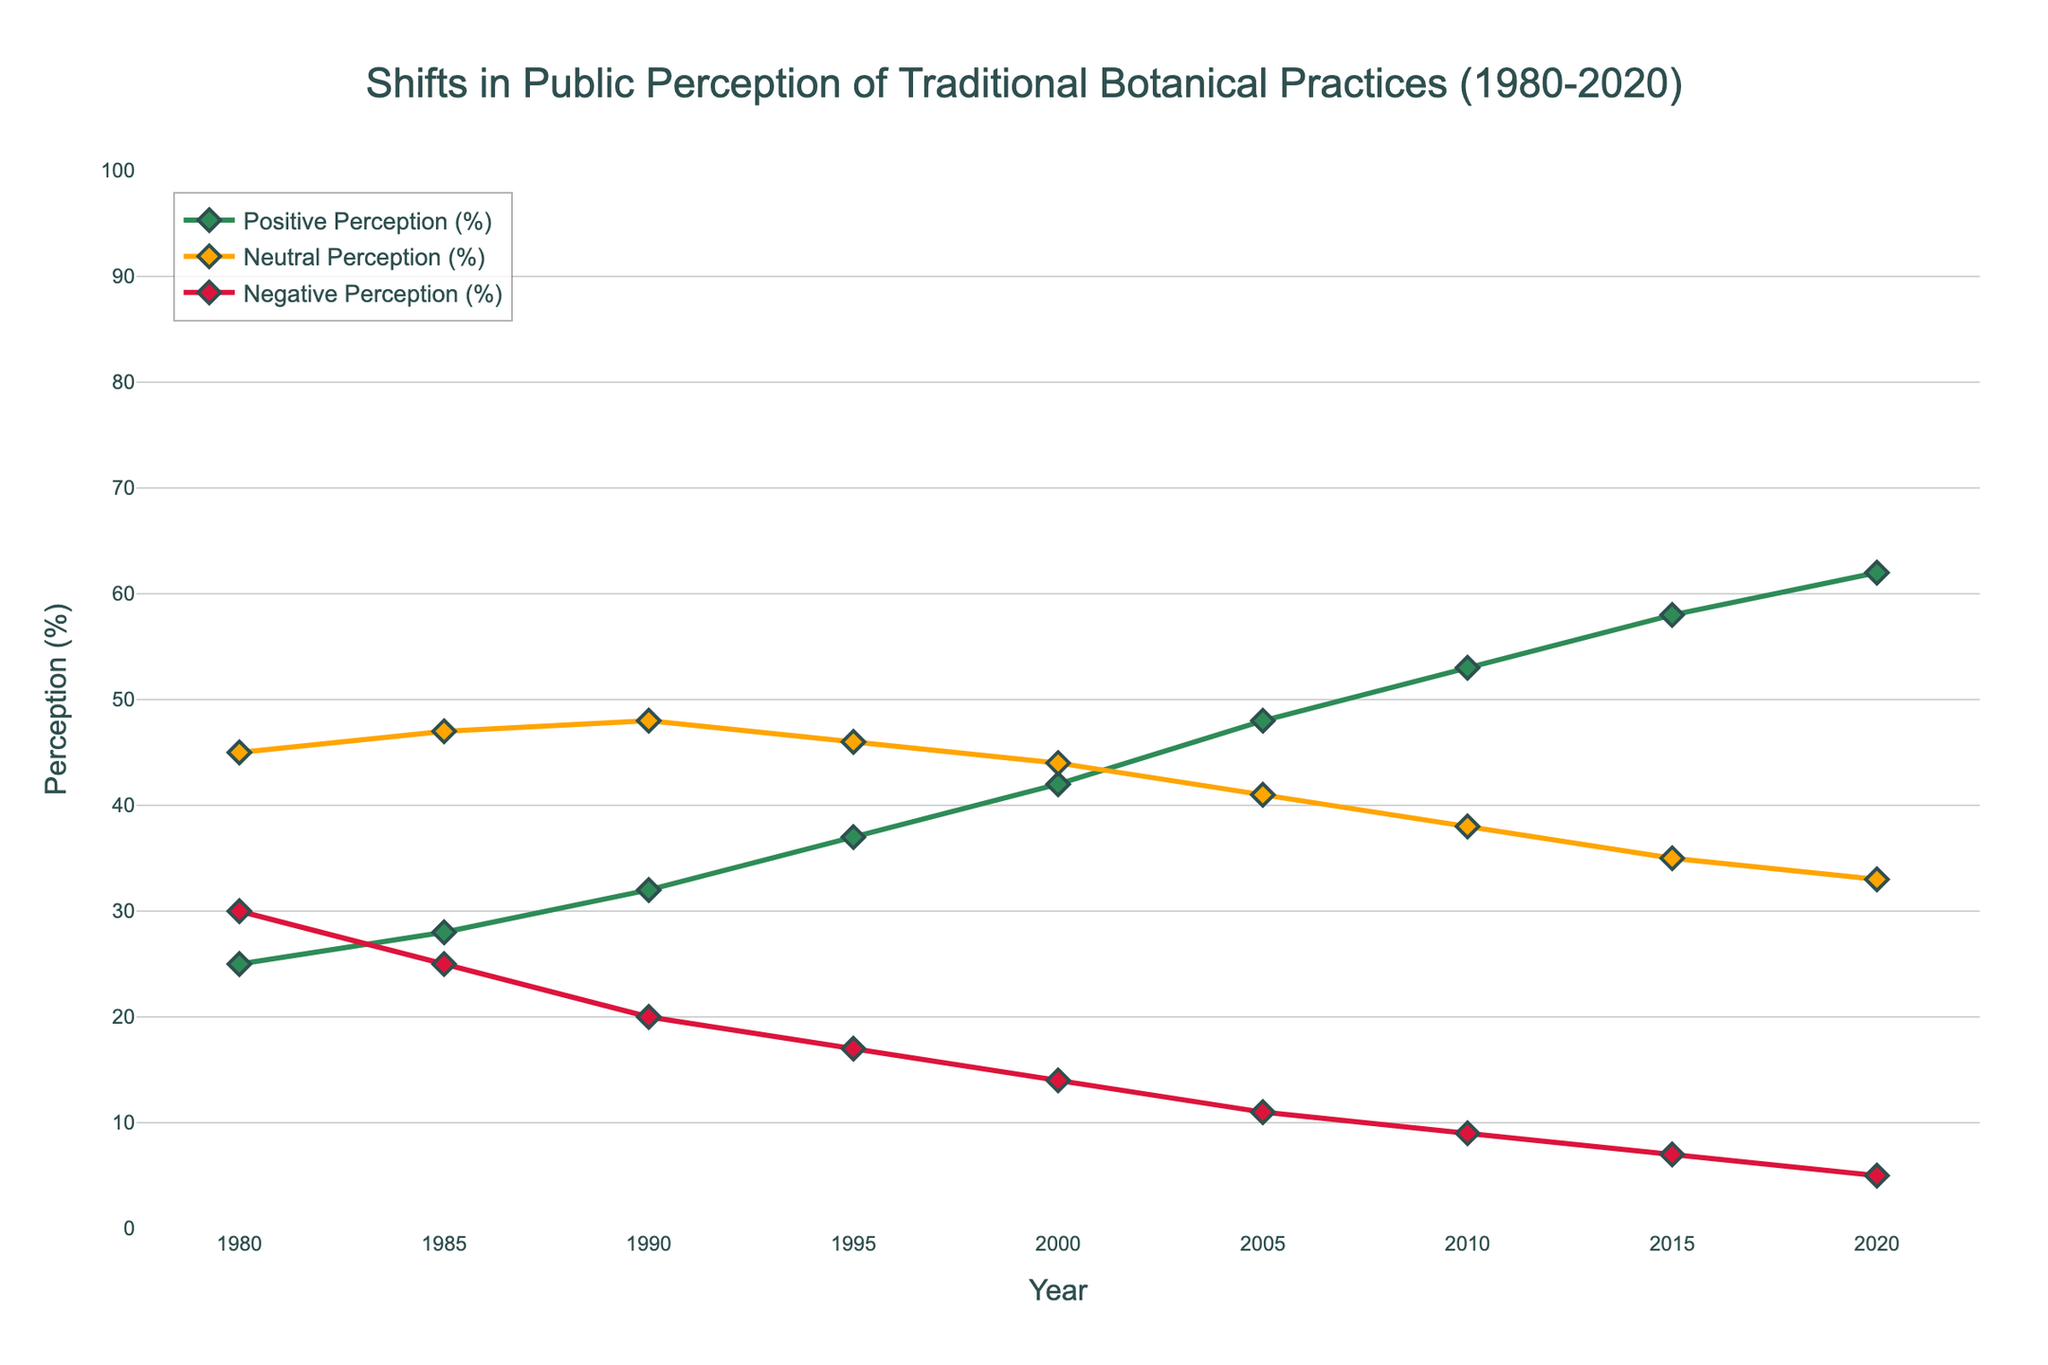What's the trend in Positive Perception (%) from 1980 to 2020? To find the trend, observe the changes in the line corresponding to Positive Perception (%). The values increase from 25% in 1980 to 62% in 2020, showing an upward trend.
Answer: Upward trend Which perception category has the lowest percentage in 2020? Identify the lowest point among the three perception lines in 2020. The Positive Perception line is at 62%, Neutral Perception is at 33%, and Negative Perception is at 5%. The lowest value is for Negative Perception.
Answer: Negative Perception (%) How does the peak value of Neutral Perception (%) compare to Negative Perception (%) throughout the years? Evaluate the highest point reached by the Neutral Perception line and compare it to the highest point of the Negative Perception line. Neutral Perception peaks at 48% in 1990, while Negative Perception reaches its highest at 30% in 1980.
Answer: Neutral Perception (%) higher Calculate the average Positive Perception (%) from 1980 to 2020. Sum the Positive Perception percentages for all given years and divide by the number of years (9). (25+28+32+37+42+48+53+58+62)/9 = 43
Answer: 43 Between which consecutive years was there the largest increase in Positive Perception (%)? Identify the periods by calculating the differences between consecutive years for Positive Perception (%). The largest increase (53 - 48 = 5%) occurs between 2005 and 2010.
Answer: 2005 to 2010 Compare the overall change in Negative Perception (%) and Positive Perception (%) from 1980 to 2020. Calculate the difference between 1980 and 2020 for both perceptions. For Negative: 30% to 5% (decrease by 25%). For Positive: 25% to 62% (increase by 37%).
Answer: Positive increased more Did the Neutral Perception (%) ever increase during the observed period? Look for any upward movement in the Neutral Perception line. It shows a slight increase between 1980 (45%) and 1990 (48%) before it starts to decline.
Answer: Yes What is the difference between the highest and lowest recorded Neutral Perception (%)? Find the maximum (48% in 1990) and minimum (33% in 2020) values of Neutral Perception and subtract them. 48 - 33 = 15
Answer: 15 Which year had the closest values for Neutral and Negative Perceptions (%)? Compare the values of these perceptions for each year and identify the smallest difference. In 1980, Neutral was 45% and Negative was 30%, a difference of 15%. 2010 is closer with Neutral at 38% and Negative at 9%, difference of 29%. So, in 1980.
Answer: 1980 